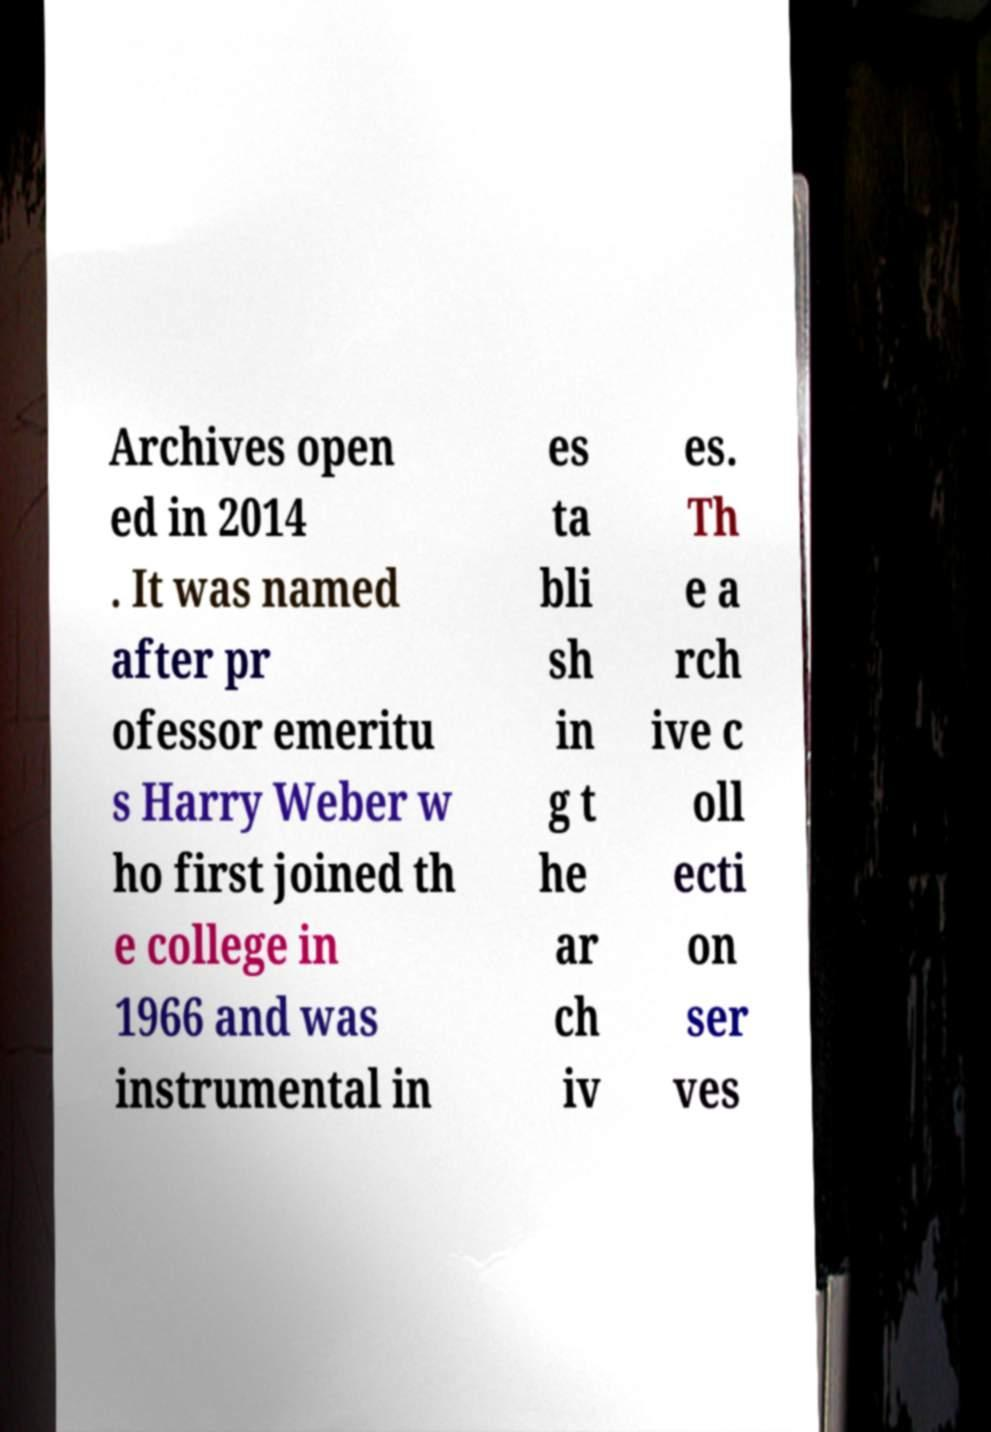Can you accurately transcribe the text from the provided image for me? Archives open ed in 2014 . It was named after pr ofessor emeritu s Harry Weber w ho first joined th e college in 1966 and was instrumental in es ta bli sh in g t he ar ch iv es. Th e a rch ive c oll ecti on ser ves 